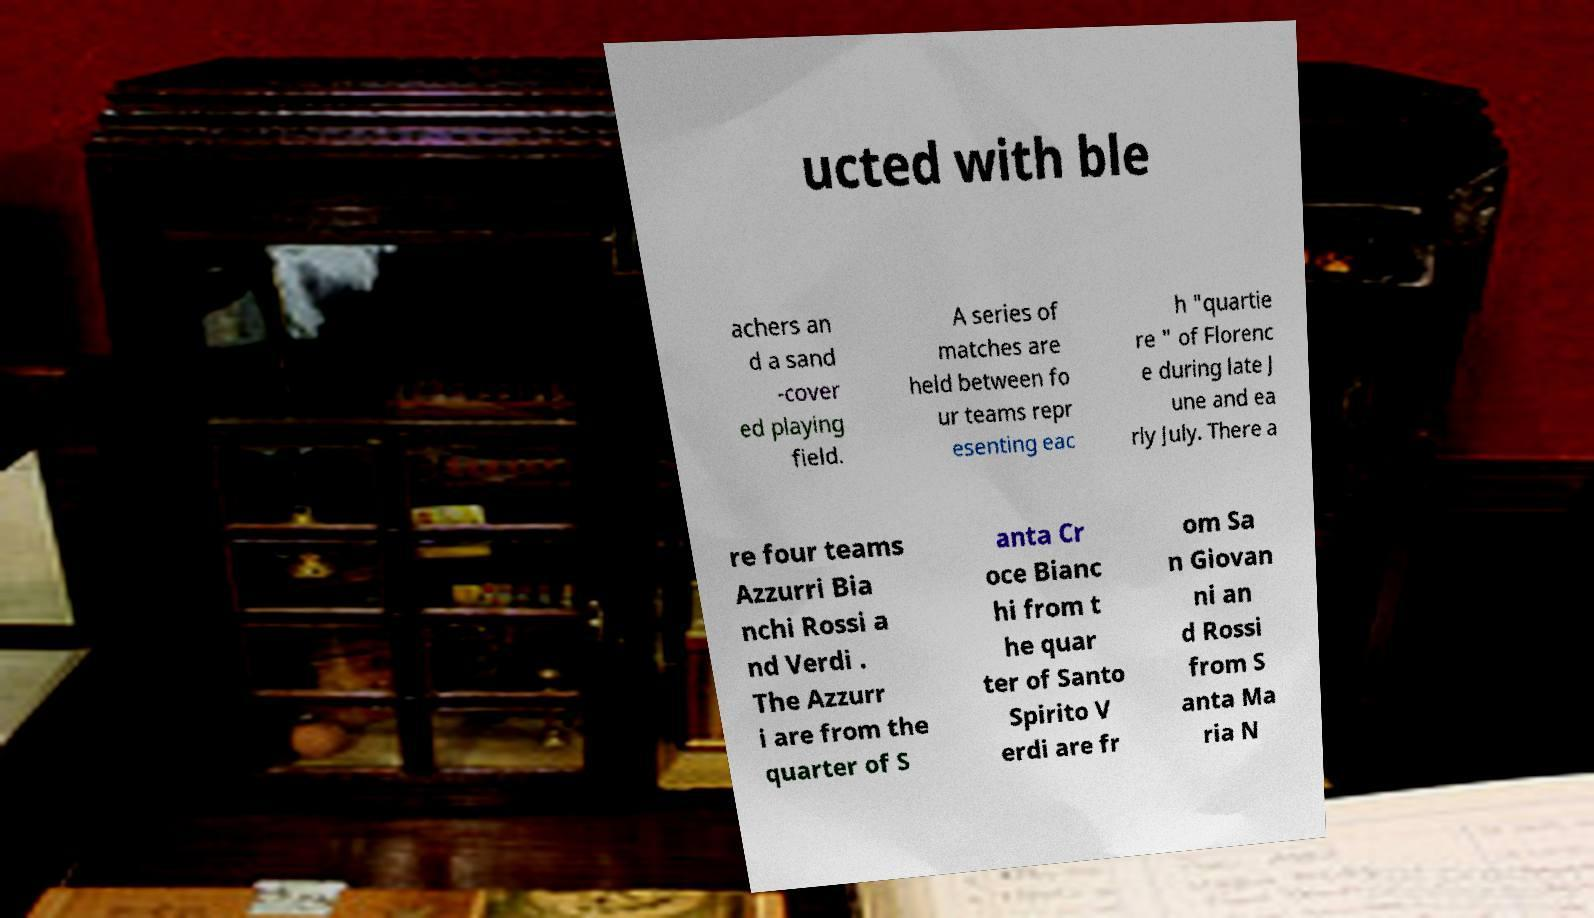There's text embedded in this image that I need extracted. Can you transcribe it verbatim? ucted with ble achers an d a sand -cover ed playing field. A series of matches are held between fo ur teams repr esenting eac h "quartie re " of Florenc e during late J une and ea rly July. There a re four teams Azzurri Bia nchi Rossi a nd Verdi . The Azzurr i are from the quarter of S anta Cr oce Bianc hi from t he quar ter of Santo Spirito V erdi are fr om Sa n Giovan ni an d Rossi from S anta Ma ria N 